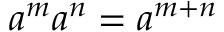Convert formula to latex. <formula><loc_0><loc_0><loc_500><loc_500>a ^ { m } a ^ { n } = a ^ { m + n }</formula> 